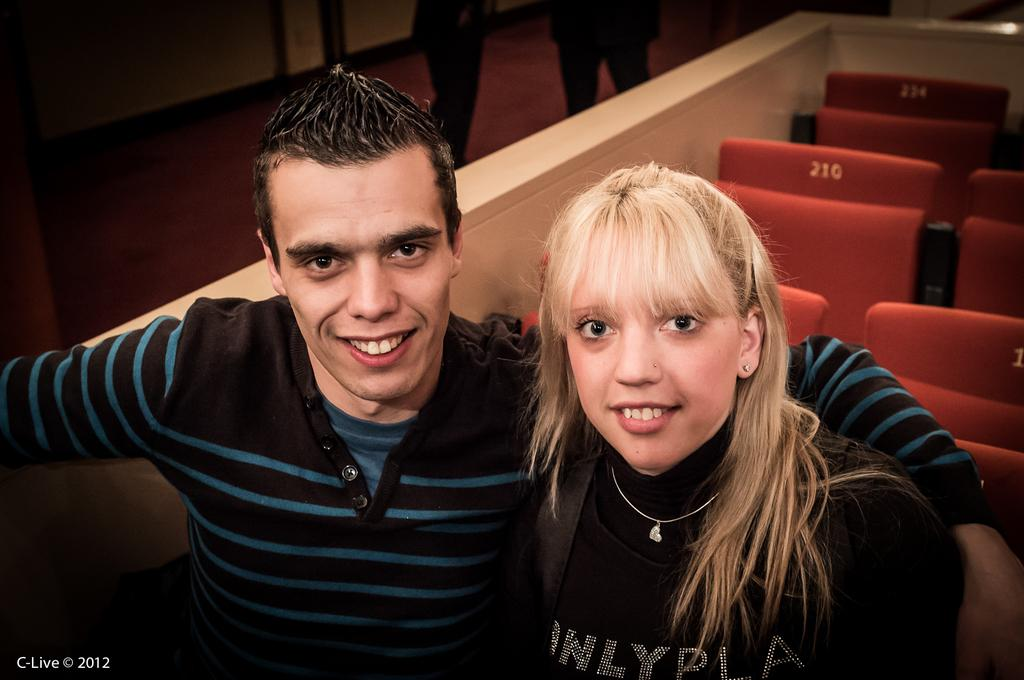How many people are in the image? There are two people in the image, a boy and a girl. What are the boy and the girl doing in the image? The boy and the girl are sitting in the front and giving a pose to the camera. What is the facial expression of the boy and the girl? The boy and the girl are both smiling in the image. What can be seen in the background of the image? There are red chairs in the background of the image. What type of authority figure is present in the image? There is no authority figure present in the image; it features a boy and a girl sitting and posing for a photo. What color is the shirt worn by the plane in the image? There is no plane present in the image, so it is not possible to determine the color of its shirt. 